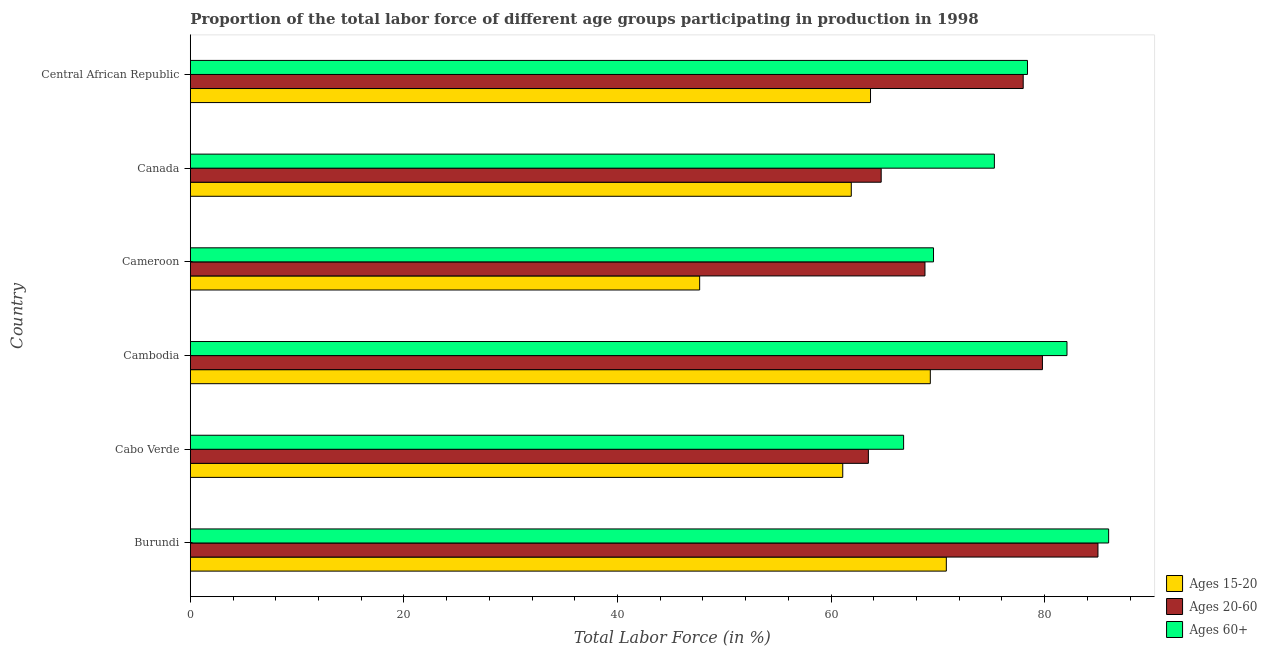How many different coloured bars are there?
Your answer should be very brief. 3. Are the number of bars per tick equal to the number of legend labels?
Offer a terse response. Yes. How many bars are there on the 2nd tick from the bottom?
Offer a very short reply. 3. In how many cases, is the number of bars for a given country not equal to the number of legend labels?
Offer a very short reply. 0. Across all countries, what is the minimum percentage of labor force within the age group 20-60?
Give a very brief answer. 63.5. In which country was the percentage of labor force within the age group 20-60 maximum?
Keep it short and to the point. Burundi. In which country was the percentage of labor force above age 60 minimum?
Provide a succinct answer. Cabo Verde. What is the total percentage of labor force within the age group 20-60 in the graph?
Offer a very short reply. 439.8. What is the difference between the percentage of labor force within the age group 15-20 in Canada and the percentage of labor force within the age group 20-60 in Cabo Verde?
Your response must be concise. -1.6. What is the average percentage of labor force above age 60 per country?
Provide a short and direct response. 76.37. What is the difference between the percentage of labor force within the age group 15-20 and percentage of labor force within the age group 20-60 in Burundi?
Ensure brevity in your answer.  -14.2. What is the ratio of the percentage of labor force within the age group 15-20 in Cabo Verde to that in Cambodia?
Offer a terse response. 0.88. Is the percentage of labor force above age 60 in Burundi less than that in Central African Republic?
Your response must be concise. No. Is the difference between the percentage of labor force within the age group 20-60 in Cambodia and Cameroon greater than the difference between the percentage of labor force above age 60 in Cambodia and Cameroon?
Keep it short and to the point. No. What does the 2nd bar from the top in Canada represents?
Offer a terse response. Ages 20-60. What does the 3rd bar from the bottom in Burundi represents?
Your response must be concise. Ages 60+. How many bars are there?
Provide a succinct answer. 18. Are all the bars in the graph horizontal?
Ensure brevity in your answer.  Yes. Does the graph contain grids?
Your answer should be compact. No. Where does the legend appear in the graph?
Make the answer very short. Bottom right. How are the legend labels stacked?
Your answer should be very brief. Vertical. What is the title of the graph?
Make the answer very short. Proportion of the total labor force of different age groups participating in production in 1998. What is the label or title of the Y-axis?
Your response must be concise. Country. What is the Total Labor Force (in %) in Ages 15-20 in Burundi?
Provide a succinct answer. 70.8. What is the Total Labor Force (in %) in Ages 15-20 in Cabo Verde?
Make the answer very short. 61.1. What is the Total Labor Force (in %) of Ages 20-60 in Cabo Verde?
Make the answer very short. 63.5. What is the Total Labor Force (in %) in Ages 60+ in Cabo Verde?
Offer a very short reply. 66.8. What is the Total Labor Force (in %) of Ages 15-20 in Cambodia?
Your response must be concise. 69.3. What is the Total Labor Force (in %) in Ages 20-60 in Cambodia?
Make the answer very short. 79.8. What is the Total Labor Force (in %) of Ages 60+ in Cambodia?
Your answer should be very brief. 82.1. What is the Total Labor Force (in %) in Ages 15-20 in Cameroon?
Ensure brevity in your answer.  47.7. What is the Total Labor Force (in %) in Ages 20-60 in Cameroon?
Keep it short and to the point. 68.8. What is the Total Labor Force (in %) in Ages 60+ in Cameroon?
Provide a short and direct response. 69.6. What is the Total Labor Force (in %) of Ages 15-20 in Canada?
Make the answer very short. 61.9. What is the Total Labor Force (in %) in Ages 20-60 in Canada?
Provide a succinct answer. 64.7. What is the Total Labor Force (in %) in Ages 60+ in Canada?
Provide a succinct answer. 75.3. What is the Total Labor Force (in %) in Ages 15-20 in Central African Republic?
Your response must be concise. 63.7. What is the Total Labor Force (in %) of Ages 20-60 in Central African Republic?
Provide a short and direct response. 78. What is the Total Labor Force (in %) of Ages 60+ in Central African Republic?
Give a very brief answer. 78.4. Across all countries, what is the maximum Total Labor Force (in %) in Ages 15-20?
Your answer should be compact. 70.8. Across all countries, what is the maximum Total Labor Force (in %) in Ages 20-60?
Make the answer very short. 85. Across all countries, what is the minimum Total Labor Force (in %) of Ages 15-20?
Make the answer very short. 47.7. Across all countries, what is the minimum Total Labor Force (in %) of Ages 20-60?
Your response must be concise. 63.5. Across all countries, what is the minimum Total Labor Force (in %) of Ages 60+?
Give a very brief answer. 66.8. What is the total Total Labor Force (in %) of Ages 15-20 in the graph?
Give a very brief answer. 374.5. What is the total Total Labor Force (in %) of Ages 20-60 in the graph?
Provide a short and direct response. 439.8. What is the total Total Labor Force (in %) of Ages 60+ in the graph?
Your answer should be compact. 458.2. What is the difference between the Total Labor Force (in %) in Ages 15-20 in Burundi and that in Cabo Verde?
Your answer should be compact. 9.7. What is the difference between the Total Labor Force (in %) of Ages 15-20 in Burundi and that in Cambodia?
Your answer should be very brief. 1.5. What is the difference between the Total Labor Force (in %) of Ages 60+ in Burundi and that in Cambodia?
Your answer should be very brief. 3.9. What is the difference between the Total Labor Force (in %) of Ages 15-20 in Burundi and that in Cameroon?
Make the answer very short. 23.1. What is the difference between the Total Labor Force (in %) of Ages 20-60 in Burundi and that in Cameroon?
Offer a very short reply. 16.2. What is the difference between the Total Labor Force (in %) of Ages 20-60 in Burundi and that in Canada?
Ensure brevity in your answer.  20.3. What is the difference between the Total Labor Force (in %) in Ages 60+ in Burundi and that in Canada?
Provide a short and direct response. 10.7. What is the difference between the Total Labor Force (in %) of Ages 15-20 in Burundi and that in Central African Republic?
Provide a succinct answer. 7.1. What is the difference between the Total Labor Force (in %) of Ages 20-60 in Burundi and that in Central African Republic?
Provide a succinct answer. 7. What is the difference between the Total Labor Force (in %) in Ages 60+ in Burundi and that in Central African Republic?
Keep it short and to the point. 7.6. What is the difference between the Total Labor Force (in %) of Ages 20-60 in Cabo Verde and that in Cambodia?
Provide a short and direct response. -16.3. What is the difference between the Total Labor Force (in %) of Ages 60+ in Cabo Verde and that in Cambodia?
Your response must be concise. -15.3. What is the difference between the Total Labor Force (in %) of Ages 20-60 in Cabo Verde and that in Cameroon?
Your answer should be compact. -5.3. What is the difference between the Total Labor Force (in %) of Ages 15-20 in Cabo Verde and that in Canada?
Provide a succinct answer. -0.8. What is the difference between the Total Labor Force (in %) of Ages 20-60 in Cabo Verde and that in Canada?
Your response must be concise. -1.2. What is the difference between the Total Labor Force (in %) of Ages 15-20 in Cambodia and that in Cameroon?
Make the answer very short. 21.6. What is the difference between the Total Labor Force (in %) in Ages 60+ in Cambodia and that in Cameroon?
Your response must be concise. 12.5. What is the difference between the Total Labor Force (in %) of Ages 15-20 in Cambodia and that in Canada?
Provide a succinct answer. 7.4. What is the difference between the Total Labor Force (in %) of Ages 20-60 in Cambodia and that in Canada?
Keep it short and to the point. 15.1. What is the difference between the Total Labor Force (in %) of Ages 15-20 in Cambodia and that in Central African Republic?
Offer a terse response. 5.6. What is the difference between the Total Labor Force (in %) of Ages 20-60 in Cambodia and that in Central African Republic?
Offer a terse response. 1.8. What is the difference between the Total Labor Force (in %) of Ages 15-20 in Cameroon and that in Canada?
Provide a short and direct response. -14.2. What is the difference between the Total Labor Force (in %) of Ages 20-60 in Cameroon and that in Canada?
Make the answer very short. 4.1. What is the difference between the Total Labor Force (in %) of Ages 60+ in Cameroon and that in Canada?
Give a very brief answer. -5.7. What is the difference between the Total Labor Force (in %) in Ages 20-60 in Cameroon and that in Central African Republic?
Keep it short and to the point. -9.2. What is the difference between the Total Labor Force (in %) in Ages 20-60 in Canada and that in Central African Republic?
Ensure brevity in your answer.  -13.3. What is the difference between the Total Labor Force (in %) in Ages 15-20 in Burundi and the Total Labor Force (in %) in Ages 60+ in Cabo Verde?
Provide a short and direct response. 4. What is the difference between the Total Labor Force (in %) of Ages 20-60 in Burundi and the Total Labor Force (in %) of Ages 60+ in Cabo Verde?
Offer a terse response. 18.2. What is the difference between the Total Labor Force (in %) of Ages 15-20 in Burundi and the Total Labor Force (in %) of Ages 60+ in Cambodia?
Your answer should be very brief. -11.3. What is the difference between the Total Labor Force (in %) in Ages 15-20 in Burundi and the Total Labor Force (in %) in Ages 20-60 in Cameroon?
Your response must be concise. 2. What is the difference between the Total Labor Force (in %) of Ages 15-20 in Burundi and the Total Labor Force (in %) of Ages 60+ in Cameroon?
Provide a short and direct response. 1.2. What is the difference between the Total Labor Force (in %) in Ages 20-60 in Burundi and the Total Labor Force (in %) in Ages 60+ in Cameroon?
Provide a succinct answer. 15.4. What is the difference between the Total Labor Force (in %) in Ages 15-20 in Burundi and the Total Labor Force (in %) in Ages 20-60 in Canada?
Offer a terse response. 6.1. What is the difference between the Total Labor Force (in %) in Ages 15-20 in Burundi and the Total Labor Force (in %) in Ages 60+ in Canada?
Ensure brevity in your answer.  -4.5. What is the difference between the Total Labor Force (in %) in Ages 15-20 in Burundi and the Total Labor Force (in %) in Ages 20-60 in Central African Republic?
Offer a very short reply. -7.2. What is the difference between the Total Labor Force (in %) in Ages 15-20 in Burundi and the Total Labor Force (in %) in Ages 60+ in Central African Republic?
Make the answer very short. -7.6. What is the difference between the Total Labor Force (in %) in Ages 20-60 in Burundi and the Total Labor Force (in %) in Ages 60+ in Central African Republic?
Provide a short and direct response. 6.6. What is the difference between the Total Labor Force (in %) in Ages 15-20 in Cabo Verde and the Total Labor Force (in %) in Ages 20-60 in Cambodia?
Give a very brief answer. -18.7. What is the difference between the Total Labor Force (in %) in Ages 20-60 in Cabo Verde and the Total Labor Force (in %) in Ages 60+ in Cambodia?
Offer a very short reply. -18.6. What is the difference between the Total Labor Force (in %) of Ages 15-20 in Cabo Verde and the Total Labor Force (in %) of Ages 20-60 in Cameroon?
Make the answer very short. -7.7. What is the difference between the Total Labor Force (in %) in Ages 15-20 in Cabo Verde and the Total Labor Force (in %) in Ages 20-60 in Canada?
Your response must be concise. -3.6. What is the difference between the Total Labor Force (in %) in Ages 15-20 in Cabo Verde and the Total Labor Force (in %) in Ages 60+ in Canada?
Provide a short and direct response. -14.2. What is the difference between the Total Labor Force (in %) of Ages 15-20 in Cabo Verde and the Total Labor Force (in %) of Ages 20-60 in Central African Republic?
Offer a terse response. -16.9. What is the difference between the Total Labor Force (in %) of Ages 15-20 in Cabo Verde and the Total Labor Force (in %) of Ages 60+ in Central African Republic?
Offer a terse response. -17.3. What is the difference between the Total Labor Force (in %) in Ages 20-60 in Cabo Verde and the Total Labor Force (in %) in Ages 60+ in Central African Republic?
Keep it short and to the point. -14.9. What is the difference between the Total Labor Force (in %) in Ages 15-20 in Cambodia and the Total Labor Force (in %) in Ages 20-60 in Cameroon?
Your response must be concise. 0.5. What is the difference between the Total Labor Force (in %) in Ages 15-20 in Cambodia and the Total Labor Force (in %) in Ages 60+ in Central African Republic?
Give a very brief answer. -9.1. What is the difference between the Total Labor Force (in %) of Ages 15-20 in Cameroon and the Total Labor Force (in %) of Ages 20-60 in Canada?
Give a very brief answer. -17. What is the difference between the Total Labor Force (in %) of Ages 15-20 in Cameroon and the Total Labor Force (in %) of Ages 60+ in Canada?
Your response must be concise. -27.6. What is the difference between the Total Labor Force (in %) of Ages 15-20 in Cameroon and the Total Labor Force (in %) of Ages 20-60 in Central African Republic?
Your response must be concise. -30.3. What is the difference between the Total Labor Force (in %) of Ages 15-20 in Cameroon and the Total Labor Force (in %) of Ages 60+ in Central African Republic?
Offer a terse response. -30.7. What is the difference between the Total Labor Force (in %) of Ages 15-20 in Canada and the Total Labor Force (in %) of Ages 20-60 in Central African Republic?
Provide a short and direct response. -16.1. What is the difference between the Total Labor Force (in %) in Ages 15-20 in Canada and the Total Labor Force (in %) in Ages 60+ in Central African Republic?
Your answer should be very brief. -16.5. What is the difference between the Total Labor Force (in %) in Ages 20-60 in Canada and the Total Labor Force (in %) in Ages 60+ in Central African Republic?
Offer a terse response. -13.7. What is the average Total Labor Force (in %) in Ages 15-20 per country?
Keep it short and to the point. 62.42. What is the average Total Labor Force (in %) in Ages 20-60 per country?
Your response must be concise. 73.3. What is the average Total Labor Force (in %) in Ages 60+ per country?
Give a very brief answer. 76.37. What is the difference between the Total Labor Force (in %) in Ages 15-20 and Total Labor Force (in %) in Ages 20-60 in Burundi?
Make the answer very short. -14.2. What is the difference between the Total Labor Force (in %) of Ages 15-20 and Total Labor Force (in %) of Ages 60+ in Burundi?
Your response must be concise. -15.2. What is the difference between the Total Labor Force (in %) in Ages 15-20 and Total Labor Force (in %) in Ages 20-60 in Cabo Verde?
Give a very brief answer. -2.4. What is the difference between the Total Labor Force (in %) of Ages 20-60 and Total Labor Force (in %) of Ages 60+ in Cambodia?
Provide a short and direct response. -2.3. What is the difference between the Total Labor Force (in %) in Ages 15-20 and Total Labor Force (in %) in Ages 20-60 in Cameroon?
Your response must be concise. -21.1. What is the difference between the Total Labor Force (in %) in Ages 15-20 and Total Labor Force (in %) in Ages 60+ in Cameroon?
Your answer should be compact. -21.9. What is the difference between the Total Labor Force (in %) of Ages 20-60 and Total Labor Force (in %) of Ages 60+ in Cameroon?
Your answer should be compact. -0.8. What is the difference between the Total Labor Force (in %) in Ages 15-20 and Total Labor Force (in %) in Ages 60+ in Canada?
Offer a terse response. -13.4. What is the difference between the Total Labor Force (in %) of Ages 15-20 and Total Labor Force (in %) of Ages 20-60 in Central African Republic?
Offer a terse response. -14.3. What is the difference between the Total Labor Force (in %) in Ages 15-20 and Total Labor Force (in %) in Ages 60+ in Central African Republic?
Make the answer very short. -14.7. What is the ratio of the Total Labor Force (in %) of Ages 15-20 in Burundi to that in Cabo Verde?
Make the answer very short. 1.16. What is the ratio of the Total Labor Force (in %) of Ages 20-60 in Burundi to that in Cabo Verde?
Ensure brevity in your answer.  1.34. What is the ratio of the Total Labor Force (in %) of Ages 60+ in Burundi to that in Cabo Verde?
Your answer should be compact. 1.29. What is the ratio of the Total Labor Force (in %) in Ages 15-20 in Burundi to that in Cambodia?
Ensure brevity in your answer.  1.02. What is the ratio of the Total Labor Force (in %) in Ages 20-60 in Burundi to that in Cambodia?
Your response must be concise. 1.07. What is the ratio of the Total Labor Force (in %) in Ages 60+ in Burundi to that in Cambodia?
Offer a terse response. 1.05. What is the ratio of the Total Labor Force (in %) of Ages 15-20 in Burundi to that in Cameroon?
Ensure brevity in your answer.  1.48. What is the ratio of the Total Labor Force (in %) of Ages 20-60 in Burundi to that in Cameroon?
Ensure brevity in your answer.  1.24. What is the ratio of the Total Labor Force (in %) of Ages 60+ in Burundi to that in Cameroon?
Offer a very short reply. 1.24. What is the ratio of the Total Labor Force (in %) of Ages 15-20 in Burundi to that in Canada?
Your answer should be compact. 1.14. What is the ratio of the Total Labor Force (in %) in Ages 20-60 in Burundi to that in Canada?
Offer a terse response. 1.31. What is the ratio of the Total Labor Force (in %) in Ages 60+ in Burundi to that in Canada?
Make the answer very short. 1.14. What is the ratio of the Total Labor Force (in %) in Ages 15-20 in Burundi to that in Central African Republic?
Your response must be concise. 1.11. What is the ratio of the Total Labor Force (in %) in Ages 20-60 in Burundi to that in Central African Republic?
Provide a short and direct response. 1.09. What is the ratio of the Total Labor Force (in %) in Ages 60+ in Burundi to that in Central African Republic?
Offer a very short reply. 1.1. What is the ratio of the Total Labor Force (in %) of Ages 15-20 in Cabo Verde to that in Cambodia?
Provide a short and direct response. 0.88. What is the ratio of the Total Labor Force (in %) in Ages 20-60 in Cabo Verde to that in Cambodia?
Make the answer very short. 0.8. What is the ratio of the Total Labor Force (in %) in Ages 60+ in Cabo Verde to that in Cambodia?
Offer a terse response. 0.81. What is the ratio of the Total Labor Force (in %) of Ages 15-20 in Cabo Verde to that in Cameroon?
Your response must be concise. 1.28. What is the ratio of the Total Labor Force (in %) of Ages 20-60 in Cabo Verde to that in Cameroon?
Offer a very short reply. 0.92. What is the ratio of the Total Labor Force (in %) of Ages 60+ in Cabo Verde to that in Cameroon?
Offer a terse response. 0.96. What is the ratio of the Total Labor Force (in %) of Ages 15-20 in Cabo Verde to that in Canada?
Offer a terse response. 0.99. What is the ratio of the Total Labor Force (in %) of Ages 20-60 in Cabo Verde to that in Canada?
Offer a terse response. 0.98. What is the ratio of the Total Labor Force (in %) in Ages 60+ in Cabo Verde to that in Canada?
Make the answer very short. 0.89. What is the ratio of the Total Labor Force (in %) of Ages 15-20 in Cabo Verde to that in Central African Republic?
Your response must be concise. 0.96. What is the ratio of the Total Labor Force (in %) of Ages 20-60 in Cabo Verde to that in Central African Republic?
Make the answer very short. 0.81. What is the ratio of the Total Labor Force (in %) in Ages 60+ in Cabo Verde to that in Central African Republic?
Offer a terse response. 0.85. What is the ratio of the Total Labor Force (in %) in Ages 15-20 in Cambodia to that in Cameroon?
Your response must be concise. 1.45. What is the ratio of the Total Labor Force (in %) of Ages 20-60 in Cambodia to that in Cameroon?
Provide a short and direct response. 1.16. What is the ratio of the Total Labor Force (in %) in Ages 60+ in Cambodia to that in Cameroon?
Your answer should be very brief. 1.18. What is the ratio of the Total Labor Force (in %) in Ages 15-20 in Cambodia to that in Canada?
Provide a succinct answer. 1.12. What is the ratio of the Total Labor Force (in %) of Ages 20-60 in Cambodia to that in Canada?
Make the answer very short. 1.23. What is the ratio of the Total Labor Force (in %) of Ages 60+ in Cambodia to that in Canada?
Offer a terse response. 1.09. What is the ratio of the Total Labor Force (in %) in Ages 15-20 in Cambodia to that in Central African Republic?
Provide a short and direct response. 1.09. What is the ratio of the Total Labor Force (in %) in Ages 20-60 in Cambodia to that in Central African Republic?
Provide a short and direct response. 1.02. What is the ratio of the Total Labor Force (in %) of Ages 60+ in Cambodia to that in Central African Republic?
Provide a short and direct response. 1.05. What is the ratio of the Total Labor Force (in %) in Ages 15-20 in Cameroon to that in Canada?
Give a very brief answer. 0.77. What is the ratio of the Total Labor Force (in %) in Ages 20-60 in Cameroon to that in Canada?
Offer a very short reply. 1.06. What is the ratio of the Total Labor Force (in %) in Ages 60+ in Cameroon to that in Canada?
Make the answer very short. 0.92. What is the ratio of the Total Labor Force (in %) of Ages 15-20 in Cameroon to that in Central African Republic?
Your response must be concise. 0.75. What is the ratio of the Total Labor Force (in %) in Ages 20-60 in Cameroon to that in Central African Republic?
Give a very brief answer. 0.88. What is the ratio of the Total Labor Force (in %) of Ages 60+ in Cameroon to that in Central African Republic?
Ensure brevity in your answer.  0.89. What is the ratio of the Total Labor Force (in %) of Ages 15-20 in Canada to that in Central African Republic?
Provide a succinct answer. 0.97. What is the ratio of the Total Labor Force (in %) of Ages 20-60 in Canada to that in Central African Republic?
Offer a very short reply. 0.83. What is the ratio of the Total Labor Force (in %) of Ages 60+ in Canada to that in Central African Republic?
Provide a short and direct response. 0.96. What is the difference between the highest and the second highest Total Labor Force (in %) of Ages 15-20?
Offer a terse response. 1.5. What is the difference between the highest and the second highest Total Labor Force (in %) in Ages 60+?
Ensure brevity in your answer.  3.9. What is the difference between the highest and the lowest Total Labor Force (in %) in Ages 15-20?
Your response must be concise. 23.1. 